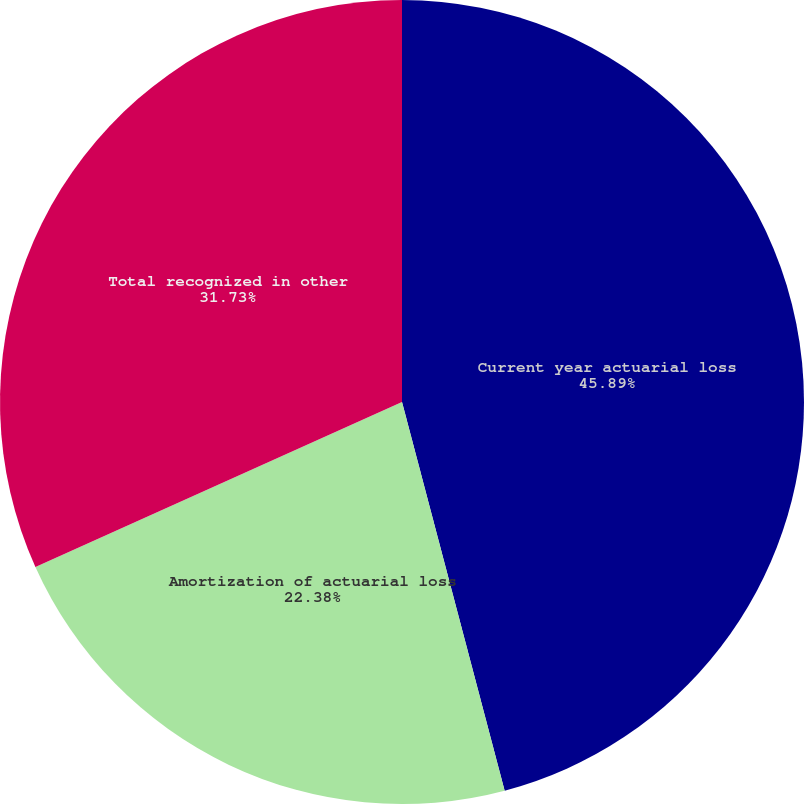Convert chart to OTSL. <chart><loc_0><loc_0><loc_500><loc_500><pie_chart><fcel>Current year actuarial loss<fcel>Amortization of actuarial loss<fcel>Total recognized in other<nl><fcel>45.89%<fcel>22.38%<fcel>31.73%<nl></chart> 